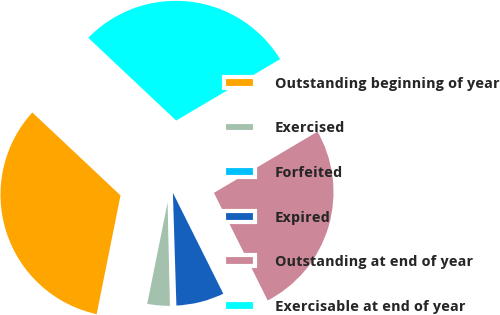Convert chart. <chart><loc_0><loc_0><loc_500><loc_500><pie_chart><fcel>Outstanding beginning of year<fcel>Exercised<fcel>Forfeited<fcel>Expired<fcel>Outstanding at end of year<fcel>Exercisable at end of year<nl><fcel>33.86%<fcel>3.51%<fcel>0.14%<fcel>6.88%<fcel>26.12%<fcel>29.49%<nl></chart> 